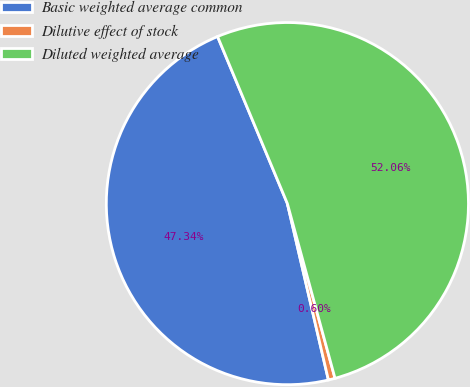<chart> <loc_0><loc_0><loc_500><loc_500><pie_chart><fcel>Basic weighted average common<fcel>Dilutive effect of stock<fcel>Diluted weighted average<nl><fcel>47.34%<fcel>0.6%<fcel>52.07%<nl></chart> 